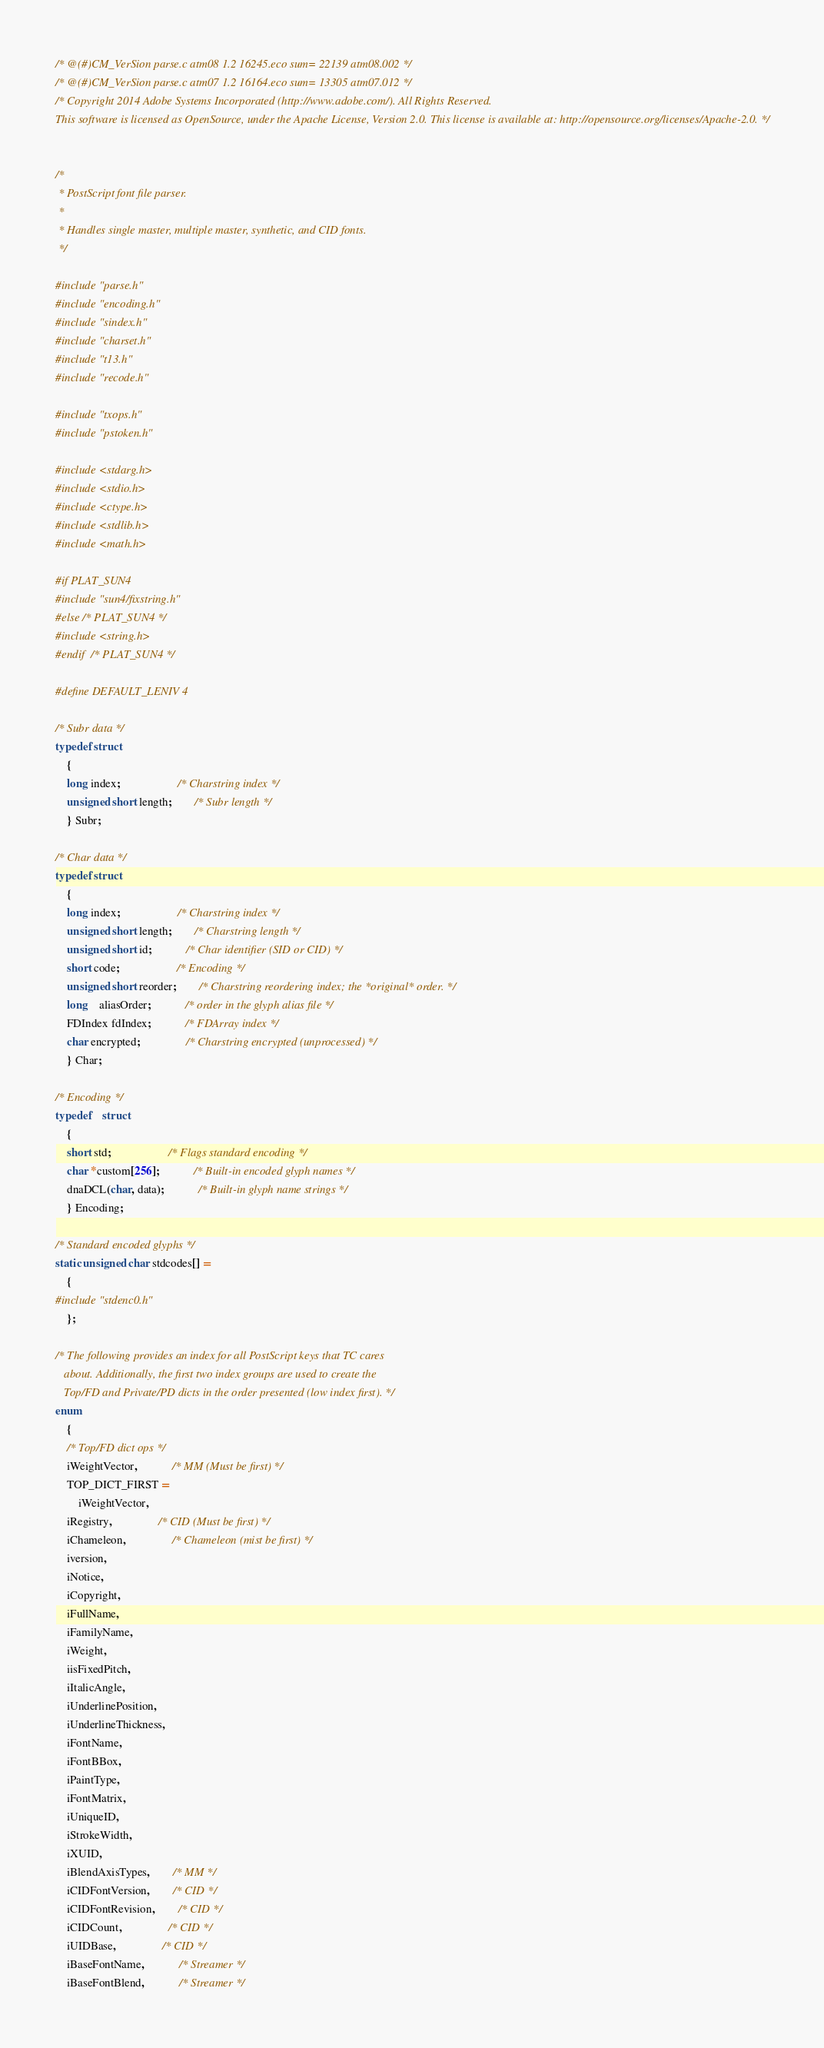Convert code to text. <code><loc_0><loc_0><loc_500><loc_500><_C_>/* @(#)CM_VerSion parse.c atm08 1.2 16245.eco sum= 22139 atm08.002 */
/* @(#)CM_VerSion parse.c atm07 1.2 16164.eco sum= 13305 atm07.012 */
/* Copyright 2014 Adobe Systems Incorporated (http://www.adobe.com/). All Rights Reserved.
This software is licensed as OpenSource, under the Apache License, Version 2.0. This license is available at: http://opensource.org/licenses/Apache-2.0. */


/*
 * PostScript font file parser. 
 *
 * Handles single master, multiple master, synthetic, and CID fonts.
 */

#include "parse.h"
#include "encoding.h"
#include "sindex.h"
#include "charset.h"
#include "t13.h"
#include "recode.h"

#include "txops.h"
#include "pstoken.h"

#include <stdarg.h>
#include <stdio.h>
#include <ctype.h>
#include <stdlib.h>
#include <math.h>

#if PLAT_SUN4
#include "sun4/fixstring.h"
#else /* PLAT_SUN4 */
#include <string.h>
#endif  /* PLAT_SUN4 */

#define DEFAULT_LENIV 4

/* Subr data */
typedef struct
	{
	long index;					/* Charstring index */
	unsigned short length;		/* Subr length */
	} Subr;

/* Char data */
typedef struct
	{
	long index;					/* Charstring index */
	unsigned short length;		/* Charstring length */
	unsigned short id;			/* Char identifier (SID or CID) */
	short code;					/* Encoding */
	unsigned short reorder;		/* Charstring reordering index; the *original* order. */
	long	aliasOrder;			/* order in the glyph alias file */
	FDIndex fdIndex;			/* FDArray index */
	char encrypted;				/* Charstring encrypted (unprocessed) */
	} Char;

/* Encoding */
typedef	struct		
	{
	short std;					/* Flags standard encoding */
	char *custom[256];			/* Built-in encoded glyph names */
	dnaDCL(char, data);			/* Built-in glyph name strings */
	} Encoding;

/* Standard encoded glyphs */
static unsigned char stdcodes[] =
	{
#include "stdenc0.h"
	};

/* The following provides an index for all PostScript keys that TC cares
   about. Additionally, the first two index groups are used to create the
   Top/FD and Private/PD dicts in the order presented (low index first). */
enum	
	{
	/* Top/FD dict ops */
	iWeightVector,			/* MM (Must be first) */
	TOP_DICT_FIRST = 
		iWeightVector,
	iRegistry,				/* CID (Must be first) */
	iChameleon,				/* Chameleon (mist be first) */
	iversion,
	iNotice,
	iCopyright,				
	iFullName,				
	iFamilyName,			
	iWeight,				
	iisFixedPitch,			
	iItalicAngle,			
	iUnderlinePosition,		
	iUnderlineThickness,	
	iFontName,
	iFontBBox,				
	iPaintType,				
	iFontMatrix,			
	iUniqueID,				
	iStrokeWidth,			
	iXUID,					
	iBlendAxisTypes,		/* MM */
	iCIDFontVersion,		/* CID */
	iCIDFontRevision,		/* CID */
	iCIDCount,				/* CID */
	iUIDBase,				/* CID */
	iBaseFontName,			/* Streamer */
	iBaseFontBlend,			/* Streamer */</code> 